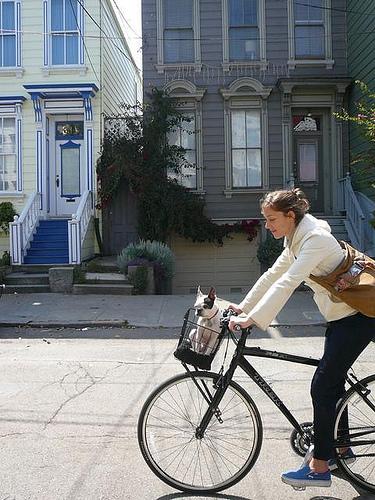What kind of animal is riding inside the basket on the bike?
Short answer required. Dog. What kind of bike is this?
Give a very brief answer. Bicycle. How many black backpacks are seen?
Short answer required. 0. Is the woman wearing glasses?
Keep it brief. No. What color is the woman's jacket?
Short answer required. White. 